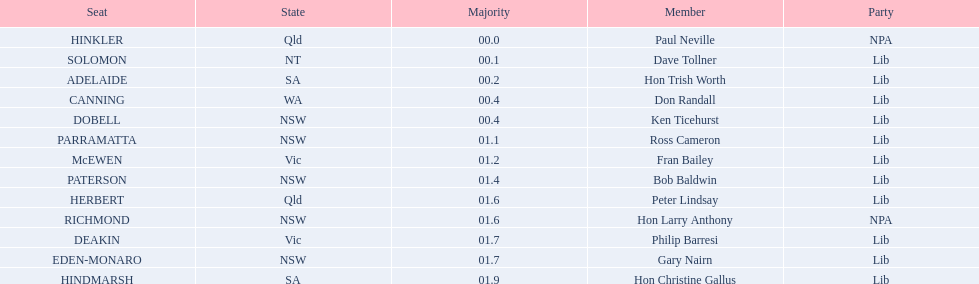What is the designation of the last chair? HINDMARSH. 